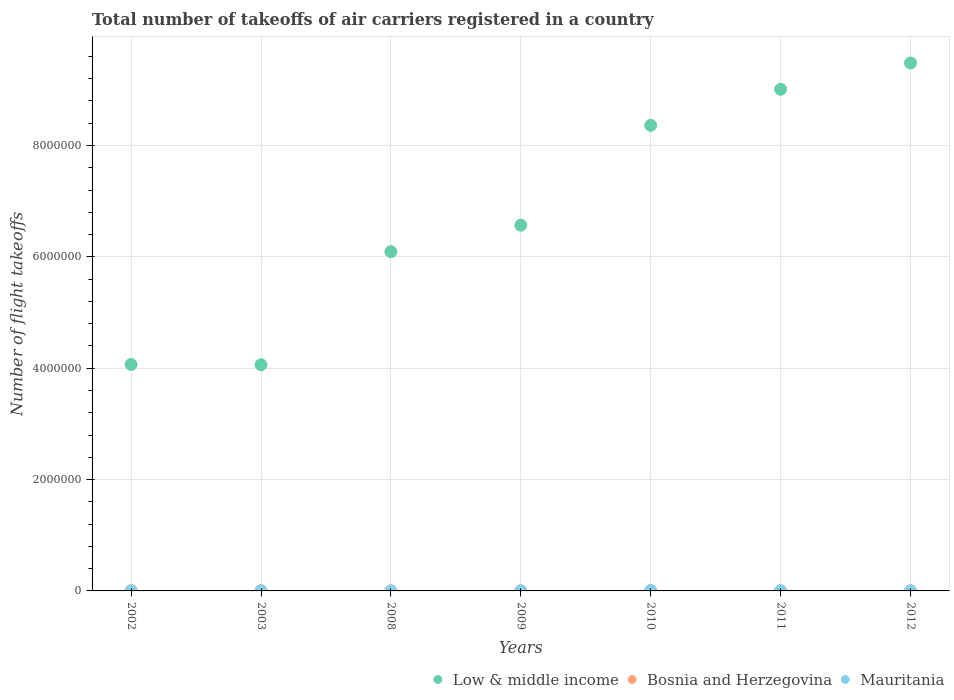How many different coloured dotlines are there?
Offer a terse response. 3. What is the total number of flight takeoffs in Bosnia and Herzegovina in 2012?
Your answer should be very brief. 750.07. Across all years, what is the maximum total number of flight takeoffs in Bosnia and Herzegovina?
Offer a terse response. 4570. Across all years, what is the minimum total number of flight takeoffs in Low & middle income?
Keep it short and to the point. 4.06e+06. In which year was the total number of flight takeoffs in Mauritania maximum?
Make the answer very short. 2010. In which year was the total number of flight takeoffs in Bosnia and Herzegovina minimum?
Provide a short and direct response. 2012. What is the total total number of flight takeoffs in Low & middle income in the graph?
Provide a short and direct response. 4.76e+07. What is the difference between the total number of flight takeoffs in Bosnia and Herzegovina in 2003 and that in 2008?
Offer a terse response. 3566. What is the difference between the total number of flight takeoffs in Low & middle income in 2010 and the total number of flight takeoffs in Bosnia and Herzegovina in 2008?
Your answer should be compact. 8.36e+06. What is the average total number of flight takeoffs in Bosnia and Herzegovina per year?
Provide a short and direct response. 2101.53. In the year 2002, what is the difference between the total number of flight takeoffs in Mauritania and total number of flight takeoffs in Bosnia and Herzegovina?
Keep it short and to the point. -2884. In how many years, is the total number of flight takeoffs in Bosnia and Herzegovina greater than 8400000?
Give a very brief answer. 0. What is the ratio of the total number of flight takeoffs in Mauritania in 2011 to that in 2012?
Give a very brief answer. 1.38. Is the total number of flight takeoffs in Mauritania in 2002 less than that in 2011?
Your answer should be very brief. Yes. Is the difference between the total number of flight takeoffs in Mauritania in 2003 and 2011 greater than the difference between the total number of flight takeoffs in Bosnia and Herzegovina in 2003 and 2011?
Make the answer very short. No. What is the difference between the highest and the second highest total number of flight takeoffs in Mauritania?
Keep it short and to the point. 2138. What is the difference between the highest and the lowest total number of flight takeoffs in Low & middle income?
Your response must be concise. 5.42e+06. In how many years, is the total number of flight takeoffs in Low & middle income greater than the average total number of flight takeoffs in Low & middle income taken over all years?
Provide a succinct answer. 3. Is the total number of flight takeoffs in Low & middle income strictly less than the total number of flight takeoffs in Bosnia and Herzegovina over the years?
Your response must be concise. No. Does the graph contain grids?
Keep it short and to the point. Yes. What is the title of the graph?
Provide a short and direct response. Total number of takeoffs of air carriers registered in a country. What is the label or title of the Y-axis?
Your response must be concise. Number of flight takeoffs. What is the Number of flight takeoffs in Low & middle income in 2002?
Offer a terse response. 4.07e+06. What is the Number of flight takeoffs in Bosnia and Herzegovina in 2002?
Your answer should be compact. 4394. What is the Number of flight takeoffs of Mauritania in 2002?
Offer a very short reply. 1510. What is the Number of flight takeoffs in Low & middle income in 2003?
Provide a succinct answer. 4.06e+06. What is the Number of flight takeoffs of Bosnia and Herzegovina in 2003?
Make the answer very short. 4570. What is the Number of flight takeoffs of Mauritania in 2003?
Your answer should be very brief. 1612. What is the Number of flight takeoffs of Low & middle income in 2008?
Provide a succinct answer. 6.09e+06. What is the Number of flight takeoffs of Bosnia and Herzegovina in 2008?
Your answer should be very brief. 1004. What is the Number of flight takeoffs in Mauritania in 2008?
Give a very brief answer. 1159. What is the Number of flight takeoffs in Low & middle income in 2009?
Give a very brief answer. 6.57e+06. What is the Number of flight takeoffs of Bosnia and Herzegovina in 2009?
Offer a very short reply. 1359. What is the Number of flight takeoffs of Mauritania in 2009?
Your answer should be very brief. 1114. What is the Number of flight takeoffs in Low & middle income in 2010?
Provide a short and direct response. 8.36e+06. What is the Number of flight takeoffs of Bosnia and Herzegovina in 2010?
Offer a terse response. 1573.55. What is the Number of flight takeoffs in Mauritania in 2010?
Give a very brief answer. 6373. What is the Number of flight takeoffs of Low & middle income in 2011?
Provide a succinct answer. 9.01e+06. What is the Number of flight takeoffs of Bosnia and Herzegovina in 2011?
Make the answer very short. 1060.07. What is the Number of flight takeoffs in Mauritania in 2011?
Offer a terse response. 4235. What is the Number of flight takeoffs in Low & middle income in 2012?
Give a very brief answer. 9.48e+06. What is the Number of flight takeoffs of Bosnia and Herzegovina in 2012?
Provide a short and direct response. 750.07. What is the Number of flight takeoffs of Mauritania in 2012?
Offer a very short reply. 3077. Across all years, what is the maximum Number of flight takeoffs in Low & middle income?
Your answer should be very brief. 9.48e+06. Across all years, what is the maximum Number of flight takeoffs in Bosnia and Herzegovina?
Provide a short and direct response. 4570. Across all years, what is the maximum Number of flight takeoffs in Mauritania?
Your answer should be compact. 6373. Across all years, what is the minimum Number of flight takeoffs of Low & middle income?
Provide a short and direct response. 4.06e+06. Across all years, what is the minimum Number of flight takeoffs in Bosnia and Herzegovina?
Offer a very short reply. 750.07. Across all years, what is the minimum Number of flight takeoffs in Mauritania?
Keep it short and to the point. 1114. What is the total Number of flight takeoffs in Low & middle income in the graph?
Your answer should be very brief. 4.76e+07. What is the total Number of flight takeoffs in Bosnia and Herzegovina in the graph?
Make the answer very short. 1.47e+04. What is the total Number of flight takeoffs in Mauritania in the graph?
Your response must be concise. 1.91e+04. What is the difference between the Number of flight takeoffs in Low & middle income in 2002 and that in 2003?
Give a very brief answer. 4485. What is the difference between the Number of flight takeoffs of Bosnia and Herzegovina in 2002 and that in 2003?
Provide a succinct answer. -176. What is the difference between the Number of flight takeoffs in Mauritania in 2002 and that in 2003?
Keep it short and to the point. -102. What is the difference between the Number of flight takeoffs in Low & middle income in 2002 and that in 2008?
Your response must be concise. -2.03e+06. What is the difference between the Number of flight takeoffs in Bosnia and Herzegovina in 2002 and that in 2008?
Offer a very short reply. 3390. What is the difference between the Number of flight takeoffs of Mauritania in 2002 and that in 2008?
Give a very brief answer. 351. What is the difference between the Number of flight takeoffs in Low & middle income in 2002 and that in 2009?
Make the answer very short. -2.50e+06. What is the difference between the Number of flight takeoffs in Bosnia and Herzegovina in 2002 and that in 2009?
Offer a very short reply. 3035. What is the difference between the Number of flight takeoffs in Mauritania in 2002 and that in 2009?
Provide a short and direct response. 396. What is the difference between the Number of flight takeoffs of Low & middle income in 2002 and that in 2010?
Provide a succinct answer. -4.30e+06. What is the difference between the Number of flight takeoffs of Bosnia and Herzegovina in 2002 and that in 2010?
Make the answer very short. 2820.45. What is the difference between the Number of flight takeoffs of Mauritania in 2002 and that in 2010?
Provide a short and direct response. -4863. What is the difference between the Number of flight takeoffs in Low & middle income in 2002 and that in 2011?
Give a very brief answer. -4.94e+06. What is the difference between the Number of flight takeoffs in Bosnia and Herzegovina in 2002 and that in 2011?
Your answer should be very brief. 3333.93. What is the difference between the Number of flight takeoffs in Mauritania in 2002 and that in 2011?
Offer a terse response. -2725. What is the difference between the Number of flight takeoffs of Low & middle income in 2002 and that in 2012?
Ensure brevity in your answer.  -5.42e+06. What is the difference between the Number of flight takeoffs of Bosnia and Herzegovina in 2002 and that in 2012?
Ensure brevity in your answer.  3643.93. What is the difference between the Number of flight takeoffs of Mauritania in 2002 and that in 2012?
Provide a short and direct response. -1567. What is the difference between the Number of flight takeoffs of Low & middle income in 2003 and that in 2008?
Provide a succinct answer. -2.03e+06. What is the difference between the Number of flight takeoffs in Bosnia and Herzegovina in 2003 and that in 2008?
Provide a short and direct response. 3566. What is the difference between the Number of flight takeoffs in Mauritania in 2003 and that in 2008?
Make the answer very short. 453. What is the difference between the Number of flight takeoffs in Low & middle income in 2003 and that in 2009?
Provide a short and direct response. -2.51e+06. What is the difference between the Number of flight takeoffs of Bosnia and Herzegovina in 2003 and that in 2009?
Give a very brief answer. 3211. What is the difference between the Number of flight takeoffs of Mauritania in 2003 and that in 2009?
Your response must be concise. 498. What is the difference between the Number of flight takeoffs in Low & middle income in 2003 and that in 2010?
Offer a terse response. -4.30e+06. What is the difference between the Number of flight takeoffs in Bosnia and Herzegovina in 2003 and that in 2010?
Your response must be concise. 2996.45. What is the difference between the Number of flight takeoffs in Mauritania in 2003 and that in 2010?
Your response must be concise. -4761. What is the difference between the Number of flight takeoffs in Low & middle income in 2003 and that in 2011?
Your answer should be compact. -4.95e+06. What is the difference between the Number of flight takeoffs in Bosnia and Herzegovina in 2003 and that in 2011?
Make the answer very short. 3509.93. What is the difference between the Number of flight takeoffs of Mauritania in 2003 and that in 2011?
Your response must be concise. -2623. What is the difference between the Number of flight takeoffs in Low & middle income in 2003 and that in 2012?
Give a very brief answer. -5.42e+06. What is the difference between the Number of flight takeoffs of Bosnia and Herzegovina in 2003 and that in 2012?
Give a very brief answer. 3819.93. What is the difference between the Number of flight takeoffs of Mauritania in 2003 and that in 2012?
Keep it short and to the point. -1465. What is the difference between the Number of flight takeoffs of Low & middle income in 2008 and that in 2009?
Keep it short and to the point. -4.76e+05. What is the difference between the Number of flight takeoffs in Bosnia and Herzegovina in 2008 and that in 2009?
Give a very brief answer. -355. What is the difference between the Number of flight takeoffs of Low & middle income in 2008 and that in 2010?
Offer a terse response. -2.27e+06. What is the difference between the Number of flight takeoffs of Bosnia and Herzegovina in 2008 and that in 2010?
Offer a terse response. -569.55. What is the difference between the Number of flight takeoffs of Mauritania in 2008 and that in 2010?
Offer a very short reply. -5214. What is the difference between the Number of flight takeoffs in Low & middle income in 2008 and that in 2011?
Provide a short and direct response. -2.92e+06. What is the difference between the Number of flight takeoffs of Bosnia and Herzegovina in 2008 and that in 2011?
Provide a short and direct response. -56.07. What is the difference between the Number of flight takeoffs in Mauritania in 2008 and that in 2011?
Your response must be concise. -3076. What is the difference between the Number of flight takeoffs of Low & middle income in 2008 and that in 2012?
Your response must be concise. -3.39e+06. What is the difference between the Number of flight takeoffs of Bosnia and Herzegovina in 2008 and that in 2012?
Your answer should be very brief. 253.93. What is the difference between the Number of flight takeoffs of Mauritania in 2008 and that in 2012?
Offer a terse response. -1918. What is the difference between the Number of flight takeoffs of Low & middle income in 2009 and that in 2010?
Your answer should be compact. -1.79e+06. What is the difference between the Number of flight takeoffs of Bosnia and Herzegovina in 2009 and that in 2010?
Give a very brief answer. -214.55. What is the difference between the Number of flight takeoffs in Mauritania in 2009 and that in 2010?
Make the answer very short. -5259. What is the difference between the Number of flight takeoffs of Low & middle income in 2009 and that in 2011?
Offer a very short reply. -2.44e+06. What is the difference between the Number of flight takeoffs in Bosnia and Herzegovina in 2009 and that in 2011?
Ensure brevity in your answer.  298.93. What is the difference between the Number of flight takeoffs of Mauritania in 2009 and that in 2011?
Make the answer very short. -3121. What is the difference between the Number of flight takeoffs of Low & middle income in 2009 and that in 2012?
Make the answer very short. -2.91e+06. What is the difference between the Number of flight takeoffs in Bosnia and Herzegovina in 2009 and that in 2012?
Ensure brevity in your answer.  608.93. What is the difference between the Number of flight takeoffs of Mauritania in 2009 and that in 2012?
Your response must be concise. -1963. What is the difference between the Number of flight takeoffs in Low & middle income in 2010 and that in 2011?
Provide a succinct answer. -6.48e+05. What is the difference between the Number of flight takeoffs in Bosnia and Herzegovina in 2010 and that in 2011?
Your answer should be very brief. 513.48. What is the difference between the Number of flight takeoffs of Mauritania in 2010 and that in 2011?
Your answer should be very brief. 2138. What is the difference between the Number of flight takeoffs of Low & middle income in 2010 and that in 2012?
Keep it short and to the point. -1.12e+06. What is the difference between the Number of flight takeoffs of Bosnia and Herzegovina in 2010 and that in 2012?
Offer a very short reply. 823.48. What is the difference between the Number of flight takeoffs in Mauritania in 2010 and that in 2012?
Your answer should be compact. 3296. What is the difference between the Number of flight takeoffs of Low & middle income in 2011 and that in 2012?
Ensure brevity in your answer.  -4.72e+05. What is the difference between the Number of flight takeoffs of Bosnia and Herzegovina in 2011 and that in 2012?
Your response must be concise. 310. What is the difference between the Number of flight takeoffs of Mauritania in 2011 and that in 2012?
Provide a short and direct response. 1158. What is the difference between the Number of flight takeoffs of Low & middle income in 2002 and the Number of flight takeoffs of Bosnia and Herzegovina in 2003?
Ensure brevity in your answer.  4.06e+06. What is the difference between the Number of flight takeoffs in Low & middle income in 2002 and the Number of flight takeoffs in Mauritania in 2003?
Offer a very short reply. 4.07e+06. What is the difference between the Number of flight takeoffs in Bosnia and Herzegovina in 2002 and the Number of flight takeoffs in Mauritania in 2003?
Provide a succinct answer. 2782. What is the difference between the Number of flight takeoffs of Low & middle income in 2002 and the Number of flight takeoffs of Bosnia and Herzegovina in 2008?
Offer a terse response. 4.07e+06. What is the difference between the Number of flight takeoffs of Low & middle income in 2002 and the Number of flight takeoffs of Mauritania in 2008?
Your answer should be very brief. 4.07e+06. What is the difference between the Number of flight takeoffs of Bosnia and Herzegovina in 2002 and the Number of flight takeoffs of Mauritania in 2008?
Your response must be concise. 3235. What is the difference between the Number of flight takeoffs in Low & middle income in 2002 and the Number of flight takeoffs in Bosnia and Herzegovina in 2009?
Provide a succinct answer. 4.07e+06. What is the difference between the Number of flight takeoffs of Low & middle income in 2002 and the Number of flight takeoffs of Mauritania in 2009?
Provide a succinct answer. 4.07e+06. What is the difference between the Number of flight takeoffs of Bosnia and Herzegovina in 2002 and the Number of flight takeoffs of Mauritania in 2009?
Make the answer very short. 3280. What is the difference between the Number of flight takeoffs of Low & middle income in 2002 and the Number of flight takeoffs of Bosnia and Herzegovina in 2010?
Your response must be concise. 4.07e+06. What is the difference between the Number of flight takeoffs in Low & middle income in 2002 and the Number of flight takeoffs in Mauritania in 2010?
Give a very brief answer. 4.06e+06. What is the difference between the Number of flight takeoffs in Bosnia and Herzegovina in 2002 and the Number of flight takeoffs in Mauritania in 2010?
Offer a terse response. -1979. What is the difference between the Number of flight takeoffs of Low & middle income in 2002 and the Number of flight takeoffs of Bosnia and Herzegovina in 2011?
Provide a short and direct response. 4.07e+06. What is the difference between the Number of flight takeoffs of Low & middle income in 2002 and the Number of flight takeoffs of Mauritania in 2011?
Your answer should be compact. 4.06e+06. What is the difference between the Number of flight takeoffs in Bosnia and Herzegovina in 2002 and the Number of flight takeoffs in Mauritania in 2011?
Make the answer very short. 159. What is the difference between the Number of flight takeoffs in Low & middle income in 2002 and the Number of flight takeoffs in Bosnia and Herzegovina in 2012?
Keep it short and to the point. 4.07e+06. What is the difference between the Number of flight takeoffs of Low & middle income in 2002 and the Number of flight takeoffs of Mauritania in 2012?
Keep it short and to the point. 4.06e+06. What is the difference between the Number of flight takeoffs in Bosnia and Herzegovina in 2002 and the Number of flight takeoffs in Mauritania in 2012?
Your answer should be very brief. 1317. What is the difference between the Number of flight takeoffs in Low & middle income in 2003 and the Number of flight takeoffs in Bosnia and Herzegovina in 2008?
Provide a succinct answer. 4.06e+06. What is the difference between the Number of flight takeoffs in Low & middle income in 2003 and the Number of flight takeoffs in Mauritania in 2008?
Keep it short and to the point. 4.06e+06. What is the difference between the Number of flight takeoffs of Bosnia and Herzegovina in 2003 and the Number of flight takeoffs of Mauritania in 2008?
Provide a succinct answer. 3411. What is the difference between the Number of flight takeoffs in Low & middle income in 2003 and the Number of flight takeoffs in Bosnia and Herzegovina in 2009?
Provide a short and direct response. 4.06e+06. What is the difference between the Number of flight takeoffs of Low & middle income in 2003 and the Number of flight takeoffs of Mauritania in 2009?
Your answer should be very brief. 4.06e+06. What is the difference between the Number of flight takeoffs in Bosnia and Herzegovina in 2003 and the Number of flight takeoffs in Mauritania in 2009?
Make the answer very short. 3456. What is the difference between the Number of flight takeoffs of Low & middle income in 2003 and the Number of flight takeoffs of Bosnia and Herzegovina in 2010?
Your answer should be very brief. 4.06e+06. What is the difference between the Number of flight takeoffs in Low & middle income in 2003 and the Number of flight takeoffs in Mauritania in 2010?
Your response must be concise. 4.06e+06. What is the difference between the Number of flight takeoffs in Bosnia and Herzegovina in 2003 and the Number of flight takeoffs in Mauritania in 2010?
Ensure brevity in your answer.  -1803. What is the difference between the Number of flight takeoffs in Low & middle income in 2003 and the Number of flight takeoffs in Bosnia and Herzegovina in 2011?
Give a very brief answer. 4.06e+06. What is the difference between the Number of flight takeoffs in Low & middle income in 2003 and the Number of flight takeoffs in Mauritania in 2011?
Offer a terse response. 4.06e+06. What is the difference between the Number of flight takeoffs in Bosnia and Herzegovina in 2003 and the Number of flight takeoffs in Mauritania in 2011?
Offer a very short reply. 335. What is the difference between the Number of flight takeoffs of Low & middle income in 2003 and the Number of flight takeoffs of Bosnia and Herzegovina in 2012?
Give a very brief answer. 4.06e+06. What is the difference between the Number of flight takeoffs in Low & middle income in 2003 and the Number of flight takeoffs in Mauritania in 2012?
Your answer should be compact. 4.06e+06. What is the difference between the Number of flight takeoffs in Bosnia and Herzegovina in 2003 and the Number of flight takeoffs in Mauritania in 2012?
Provide a short and direct response. 1493. What is the difference between the Number of flight takeoffs in Low & middle income in 2008 and the Number of flight takeoffs in Bosnia and Herzegovina in 2009?
Your response must be concise. 6.09e+06. What is the difference between the Number of flight takeoffs of Low & middle income in 2008 and the Number of flight takeoffs of Mauritania in 2009?
Provide a short and direct response. 6.09e+06. What is the difference between the Number of flight takeoffs of Bosnia and Herzegovina in 2008 and the Number of flight takeoffs of Mauritania in 2009?
Make the answer very short. -110. What is the difference between the Number of flight takeoffs in Low & middle income in 2008 and the Number of flight takeoffs in Bosnia and Herzegovina in 2010?
Your answer should be very brief. 6.09e+06. What is the difference between the Number of flight takeoffs of Low & middle income in 2008 and the Number of flight takeoffs of Mauritania in 2010?
Your answer should be very brief. 6.09e+06. What is the difference between the Number of flight takeoffs in Bosnia and Herzegovina in 2008 and the Number of flight takeoffs in Mauritania in 2010?
Ensure brevity in your answer.  -5369. What is the difference between the Number of flight takeoffs in Low & middle income in 2008 and the Number of flight takeoffs in Bosnia and Herzegovina in 2011?
Offer a terse response. 6.09e+06. What is the difference between the Number of flight takeoffs in Low & middle income in 2008 and the Number of flight takeoffs in Mauritania in 2011?
Your response must be concise. 6.09e+06. What is the difference between the Number of flight takeoffs in Bosnia and Herzegovina in 2008 and the Number of flight takeoffs in Mauritania in 2011?
Provide a succinct answer. -3231. What is the difference between the Number of flight takeoffs in Low & middle income in 2008 and the Number of flight takeoffs in Bosnia and Herzegovina in 2012?
Provide a succinct answer. 6.09e+06. What is the difference between the Number of flight takeoffs of Low & middle income in 2008 and the Number of flight takeoffs of Mauritania in 2012?
Give a very brief answer. 6.09e+06. What is the difference between the Number of flight takeoffs of Bosnia and Herzegovina in 2008 and the Number of flight takeoffs of Mauritania in 2012?
Give a very brief answer. -2073. What is the difference between the Number of flight takeoffs in Low & middle income in 2009 and the Number of flight takeoffs in Bosnia and Herzegovina in 2010?
Provide a succinct answer. 6.57e+06. What is the difference between the Number of flight takeoffs in Low & middle income in 2009 and the Number of flight takeoffs in Mauritania in 2010?
Provide a short and direct response. 6.56e+06. What is the difference between the Number of flight takeoffs in Bosnia and Herzegovina in 2009 and the Number of flight takeoffs in Mauritania in 2010?
Your response must be concise. -5014. What is the difference between the Number of flight takeoffs in Low & middle income in 2009 and the Number of flight takeoffs in Bosnia and Herzegovina in 2011?
Offer a very short reply. 6.57e+06. What is the difference between the Number of flight takeoffs in Low & middle income in 2009 and the Number of flight takeoffs in Mauritania in 2011?
Your response must be concise. 6.56e+06. What is the difference between the Number of flight takeoffs of Bosnia and Herzegovina in 2009 and the Number of flight takeoffs of Mauritania in 2011?
Offer a terse response. -2876. What is the difference between the Number of flight takeoffs in Low & middle income in 2009 and the Number of flight takeoffs in Bosnia and Herzegovina in 2012?
Your answer should be compact. 6.57e+06. What is the difference between the Number of flight takeoffs of Low & middle income in 2009 and the Number of flight takeoffs of Mauritania in 2012?
Your response must be concise. 6.57e+06. What is the difference between the Number of flight takeoffs of Bosnia and Herzegovina in 2009 and the Number of flight takeoffs of Mauritania in 2012?
Keep it short and to the point. -1718. What is the difference between the Number of flight takeoffs in Low & middle income in 2010 and the Number of flight takeoffs in Bosnia and Herzegovina in 2011?
Offer a very short reply. 8.36e+06. What is the difference between the Number of flight takeoffs of Low & middle income in 2010 and the Number of flight takeoffs of Mauritania in 2011?
Make the answer very short. 8.36e+06. What is the difference between the Number of flight takeoffs in Bosnia and Herzegovina in 2010 and the Number of flight takeoffs in Mauritania in 2011?
Keep it short and to the point. -2661.45. What is the difference between the Number of flight takeoffs in Low & middle income in 2010 and the Number of flight takeoffs in Bosnia and Herzegovina in 2012?
Keep it short and to the point. 8.36e+06. What is the difference between the Number of flight takeoffs in Low & middle income in 2010 and the Number of flight takeoffs in Mauritania in 2012?
Give a very brief answer. 8.36e+06. What is the difference between the Number of flight takeoffs of Bosnia and Herzegovina in 2010 and the Number of flight takeoffs of Mauritania in 2012?
Offer a very short reply. -1503.45. What is the difference between the Number of flight takeoffs in Low & middle income in 2011 and the Number of flight takeoffs in Bosnia and Herzegovina in 2012?
Offer a terse response. 9.01e+06. What is the difference between the Number of flight takeoffs of Low & middle income in 2011 and the Number of flight takeoffs of Mauritania in 2012?
Your answer should be very brief. 9.01e+06. What is the difference between the Number of flight takeoffs in Bosnia and Herzegovina in 2011 and the Number of flight takeoffs in Mauritania in 2012?
Make the answer very short. -2016.93. What is the average Number of flight takeoffs of Low & middle income per year?
Offer a very short reply. 6.81e+06. What is the average Number of flight takeoffs in Bosnia and Herzegovina per year?
Give a very brief answer. 2101.53. What is the average Number of flight takeoffs in Mauritania per year?
Your answer should be compact. 2725.71. In the year 2002, what is the difference between the Number of flight takeoffs of Low & middle income and Number of flight takeoffs of Bosnia and Herzegovina?
Offer a terse response. 4.06e+06. In the year 2002, what is the difference between the Number of flight takeoffs of Low & middle income and Number of flight takeoffs of Mauritania?
Ensure brevity in your answer.  4.07e+06. In the year 2002, what is the difference between the Number of flight takeoffs in Bosnia and Herzegovina and Number of flight takeoffs in Mauritania?
Make the answer very short. 2884. In the year 2003, what is the difference between the Number of flight takeoffs of Low & middle income and Number of flight takeoffs of Bosnia and Herzegovina?
Provide a short and direct response. 4.06e+06. In the year 2003, what is the difference between the Number of flight takeoffs of Low & middle income and Number of flight takeoffs of Mauritania?
Provide a short and direct response. 4.06e+06. In the year 2003, what is the difference between the Number of flight takeoffs in Bosnia and Herzegovina and Number of flight takeoffs in Mauritania?
Provide a succinct answer. 2958. In the year 2008, what is the difference between the Number of flight takeoffs of Low & middle income and Number of flight takeoffs of Bosnia and Herzegovina?
Give a very brief answer. 6.09e+06. In the year 2008, what is the difference between the Number of flight takeoffs of Low & middle income and Number of flight takeoffs of Mauritania?
Keep it short and to the point. 6.09e+06. In the year 2008, what is the difference between the Number of flight takeoffs of Bosnia and Herzegovina and Number of flight takeoffs of Mauritania?
Make the answer very short. -155. In the year 2009, what is the difference between the Number of flight takeoffs of Low & middle income and Number of flight takeoffs of Bosnia and Herzegovina?
Your response must be concise. 6.57e+06. In the year 2009, what is the difference between the Number of flight takeoffs of Low & middle income and Number of flight takeoffs of Mauritania?
Give a very brief answer. 6.57e+06. In the year 2009, what is the difference between the Number of flight takeoffs of Bosnia and Herzegovina and Number of flight takeoffs of Mauritania?
Offer a very short reply. 245. In the year 2010, what is the difference between the Number of flight takeoffs of Low & middle income and Number of flight takeoffs of Bosnia and Herzegovina?
Ensure brevity in your answer.  8.36e+06. In the year 2010, what is the difference between the Number of flight takeoffs in Low & middle income and Number of flight takeoffs in Mauritania?
Provide a short and direct response. 8.36e+06. In the year 2010, what is the difference between the Number of flight takeoffs of Bosnia and Herzegovina and Number of flight takeoffs of Mauritania?
Provide a short and direct response. -4799.45. In the year 2011, what is the difference between the Number of flight takeoffs in Low & middle income and Number of flight takeoffs in Bosnia and Herzegovina?
Your answer should be compact. 9.01e+06. In the year 2011, what is the difference between the Number of flight takeoffs of Low & middle income and Number of flight takeoffs of Mauritania?
Your answer should be compact. 9.01e+06. In the year 2011, what is the difference between the Number of flight takeoffs of Bosnia and Herzegovina and Number of flight takeoffs of Mauritania?
Give a very brief answer. -3174.93. In the year 2012, what is the difference between the Number of flight takeoffs in Low & middle income and Number of flight takeoffs in Bosnia and Herzegovina?
Your answer should be compact. 9.48e+06. In the year 2012, what is the difference between the Number of flight takeoffs in Low & middle income and Number of flight takeoffs in Mauritania?
Give a very brief answer. 9.48e+06. In the year 2012, what is the difference between the Number of flight takeoffs in Bosnia and Herzegovina and Number of flight takeoffs in Mauritania?
Your answer should be compact. -2326.93. What is the ratio of the Number of flight takeoffs of Low & middle income in 2002 to that in 2003?
Ensure brevity in your answer.  1. What is the ratio of the Number of flight takeoffs in Bosnia and Herzegovina in 2002 to that in 2003?
Provide a succinct answer. 0.96. What is the ratio of the Number of flight takeoffs of Mauritania in 2002 to that in 2003?
Ensure brevity in your answer.  0.94. What is the ratio of the Number of flight takeoffs of Low & middle income in 2002 to that in 2008?
Provide a short and direct response. 0.67. What is the ratio of the Number of flight takeoffs of Bosnia and Herzegovina in 2002 to that in 2008?
Give a very brief answer. 4.38. What is the ratio of the Number of flight takeoffs in Mauritania in 2002 to that in 2008?
Provide a short and direct response. 1.3. What is the ratio of the Number of flight takeoffs of Low & middle income in 2002 to that in 2009?
Your answer should be compact. 0.62. What is the ratio of the Number of flight takeoffs of Bosnia and Herzegovina in 2002 to that in 2009?
Provide a succinct answer. 3.23. What is the ratio of the Number of flight takeoffs of Mauritania in 2002 to that in 2009?
Make the answer very short. 1.36. What is the ratio of the Number of flight takeoffs of Low & middle income in 2002 to that in 2010?
Your response must be concise. 0.49. What is the ratio of the Number of flight takeoffs of Bosnia and Herzegovina in 2002 to that in 2010?
Keep it short and to the point. 2.79. What is the ratio of the Number of flight takeoffs of Mauritania in 2002 to that in 2010?
Give a very brief answer. 0.24. What is the ratio of the Number of flight takeoffs of Low & middle income in 2002 to that in 2011?
Your answer should be very brief. 0.45. What is the ratio of the Number of flight takeoffs in Bosnia and Herzegovina in 2002 to that in 2011?
Your answer should be compact. 4.14. What is the ratio of the Number of flight takeoffs of Mauritania in 2002 to that in 2011?
Your answer should be very brief. 0.36. What is the ratio of the Number of flight takeoffs in Low & middle income in 2002 to that in 2012?
Give a very brief answer. 0.43. What is the ratio of the Number of flight takeoffs of Bosnia and Herzegovina in 2002 to that in 2012?
Offer a very short reply. 5.86. What is the ratio of the Number of flight takeoffs in Mauritania in 2002 to that in 2012?
Give a very brief answer. 0.49. What is the ratio of the Number of flight takeoffs of Low & middle income in 2003 to that in 2008?
Offer a terse response. 0.67. What is the ratio of the Number of flight takeoffs of Bosnia and Herzegovina in 2003 to that in 2008?
Make the answer very short. 4.55. What is the ratio of the Number of flight takeoffs of Mauritania in 2003 to that in 2008?
Make the answer very short. 1.39. What is the ratio of the Number of flight takeoffs of Low & middle income in 2003 to that in 2009?
Offer a terse response. 0.62. What is the ratio of the Number of flight takeoffs of Bosnia and Herzegovina in 2003 to that in 2009?
Your response must be concise. 3.36. What is the ratio of the Number of flight takeoffs of Mauritania in 2003 to that in 2009?
Provide a succinct answer. 1.45. What is the ratio of the Number of flight takeoffs in Low & middle income in 2003 to that in 2010?
Offer a very short reply. 0.49. What is the ratio of the Number of flight takeoffs of Bosnia and Herzegovina in 2003 to that in 2010?
Your answer should be very brief. 2.9. What is the ratio of the Number of flight takeoffs in Mauritania in 2003 to that in 2010?
Offer a very short reply. 0.25. What is the ratio of the Number of flight takeoffs of Low & middle income in 2003 to that in 2011?
Give a very brief answer. 0.45. What is the ratio of the Number of flight takeoffs in Bosnia and Herzegovina in 2003 to that in 2011?
Make the answer very short. 4.31. What is the ratio of the Number of flight takeoffs in Mauritania in 2003 to that in 2011?
Keep it short and to the point. 0.38. What is the ratio of the Number of flight takeoffs of Low & middle income in 2003 to that in 2012?
Provide a short and direct response. 0.43. What is the ratio of the Number of flight takeoffs of Bosnia and Herzegovina in 2003 to that in 2012?
Make the answer very short. 6.09. What is the ratio of the Number of flight takeoffs of Mauritania in 2003 to that in 2012?
Ensure brevity in your answer.  0.52. What is the ratio of the Number of flight takeoffs of Low & middle income in 2008 to that in 2009?
Your response must be concise. 0.93. What is the ratio of the Number of flight takeoffs in Bosnia and Herzegovina in 2008 to that in 2009?
Ensure brevity in your answer.  0.74. What is the ratio of the Number of flight takeoffs in Mauritania in 2008 to that in 2009?
Give a very brief answer. 1.04. What is the ratio of the Number of flight takeoffs in Low & middle income in 2008 to that in 2010?
Keep it short and to the point. 0.73. What is the ratio of the Number of flight takeoffs in Bosnia and Herzegovina in 2008 to that in 2010?
Make the answer very short. 0.64. What is the ratio of the Number of flight takeoffs of Mauritania in 2008 to that in 2010?
Provide a succinct answer. 0.18. What is the ratio of the Number of flight takeoffs of Low & middle income in 2008 to that in 2011?
Ensure brevity in your answer.  0.68. What is the ratio of the Number of flight takeoffs of Bosnia and Herzegovina in 2008 to that in 2011?
Make the answer very short. 0.95. What is the ratio of the Number of flight takeoffs of Mauritania in 2008 to that in 2011?
Ensure brevity in your answer.  0.27. What is the ratio of the Number of flight takeoffs of Low & middle income in 2008 to that in 2012?
Offer a terse response. 0.64. What is the ratio of the Number of flight takeoffs in Bosnia and Herzegovina in 2008 to that in 2012?
Provide a short and direct response. 1.34. What is the ratio of the Number of flight takeoffs in Mauritania in 2008 to that in 2012?
Your answer should be very brief. 0.38. What is the ratio of the Number of flight takeoffs of Low & middle income in 2009 to that in 2010?
Your response must be concise. 0.79. What is the ratio of the Number of flight takeoffs of Bosnia and Herzegovina in 2009 to that in 2010?
Keep it short and to the point. 0.86. What is the ratio of the Number of flight takeoffs in Mauritania in 2009 to that in 2010?
Your response must be concise. 0.17. What is the ratio of the Number of flight takeoffs of Low & middle income in 2009 to that in 2011?
Provide a short and direct response. 0.73. What is the ratio of the Number of flight takeoffs in Bosnia and Herzegovina in 2009 to that in 2011?
Give a very brief answer. 1.28. What is the ratio of the Number of flight takeoffs in Mauritania in 2009 to that in 2011?
Offer a terse response. 0.26. What is the ratio of the Number of flight takeoffs in Low & middle income in 2009 to that in 2012?
Offer a very short reply. 0.69. What is the ratio of the Number of flight takeoffs in Bosnia and Herzegovina in 2009 to that in 2012?
Provide a short and direct response. 1.81. What is the ratio of the Number of flight takeoffs in Mauritania in 2009 to that in 2012?
Provide a succinct answer. 0.36. What is the ratio of the Number of flight takeoffs of Low & middle income in 2010 to that in 2011?
Your response must be concise. 0.93. What is the ratio of the Number of flight takeoffs in Bosnia and Herzegovina in 2010 to that in 2011?
Offer a terse response. 1.48. What is the ratio of the Number of flight takeoffs of Mauritania in 2010 to that in 2011?
Your answer should be compact. 1.5. What is the ratio of the Number of flight takeoffs of Low & middle income in 2010 to that in 2012?
Your answer should be very brief. 0.88. What is the ratio of the Number of flight takeoffs in Bosnia and Herzegovina in 2010 to that in 2012?
Your answer should be very brief. 2.1. What is the ratio of the Number of flight takeoffs of Mauritania in 2010 to that in 2012?
Provide a succinct answer. 2.07. What is the ratio of the Number of flight takeoffs in Low & middle income in 2011 to that in 2012?
Keep it short and to the point. 0.95. What is the ratio of the Number of flight takeoffs in Bosnia and Herzegovina in 2011 to that in 2012?
Provide a short and direct response. 1.41. What is the ratio of the Number of flight takeoffs in Mauritania in 2011 to that in 2012?
Keep it short and to the point. 1.38. What is the difference between the highest and the second highest Number of flight takeoffs of Low & middle income?
Give a very brief answer. 4.72e+05. What is the difference between the highest and the second highest Number of flight takeoffs of Bosnia and Herzegovina?
Your response must be concise. 176. What is the difference between the highest and the second highest Number of flight takeoffs in Mauritania?
Your response must be concise. 2138. What is the difference between the highest and the lowest Number of flight takeoffs of Low & middle income?
Make the answer very short. 5.42e+06. What is the difference between the highest and the lowest Number of flight takeoffs in Bosnia and Herzegovina?
Keep it short and to the point. 3819.93. What is the difference between the highest and the lowest Number of flight takeoffs in Mauritania?
Your answer should be compact. 5259. 